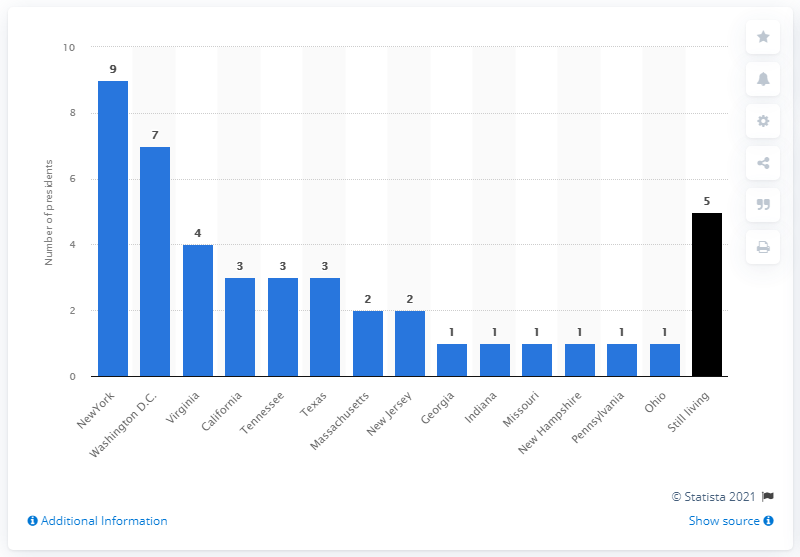Highlight a few significant elements in this photo. George Washington, Thomas Jefferson, James Madison, and James Monroe all died in the state of Virginia. 